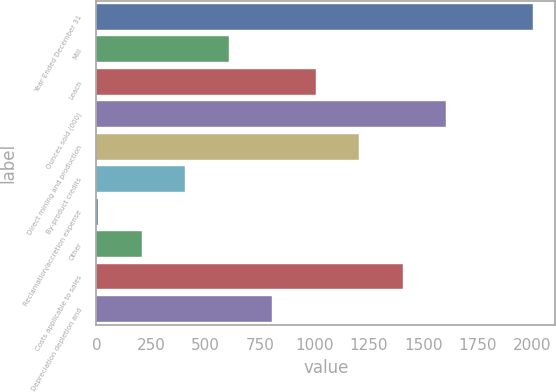Convert chart. <chart><loc_0><loc_0><loc_500><loc_500><bar_chart><fcel>Year Ended December 31<fcel>Mill<fcel>Leach<fcel>Ounces sold (000)<fcel>Direct mining and production<fcel>By-product credits<fcel>Reclamation/accretion expense<fcel>Other<fcel>Costs applicable to sales<fcel>Depreciation depletion and<nl><fcel>2006<fcel>608.1<fcel>1007.5<fcel>1606.6<fcel>1207.2<fcel>408.4<fcel>9<fcel>208.7<fcel>1406.9<fcel>807.8<nl></chart> 